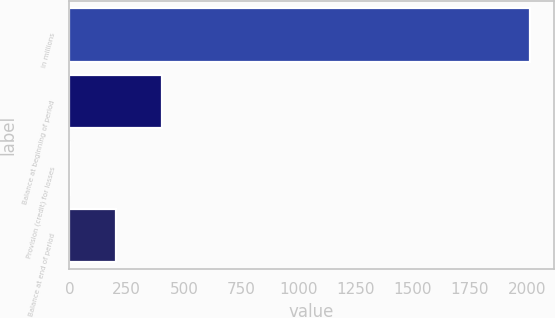Convert chart. <chart><loc_0><loc_0><loc_500><loc_500><bar_chart><fcel>in millions<fcel>Balance at beginning of period<fcel>Provision (credit) for losses<fcel>Balance at end of period<nl><fcel>2014<fcel>404.4<fcel>2<fcel>203.2<nl></chart> 